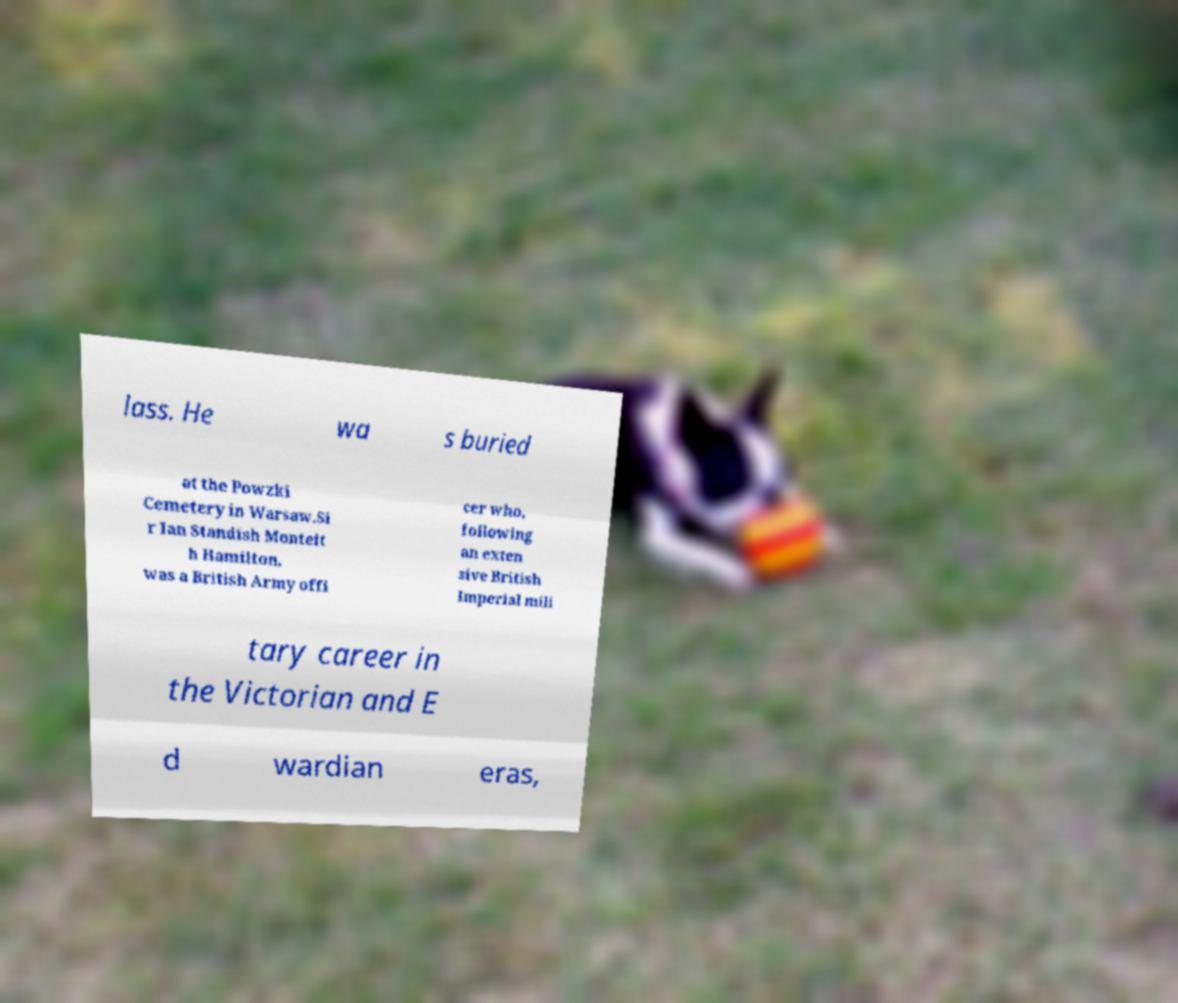Could you extract and type out the text from this image? lass. He wa s buried at the Powzki Cemetery in Warsaw.Si r Ian Standish Monteit h Hamilton, was a British Army offi cer who, following an exten sive British Imperial mili tary career in the Victorian and E d wardian eras, 